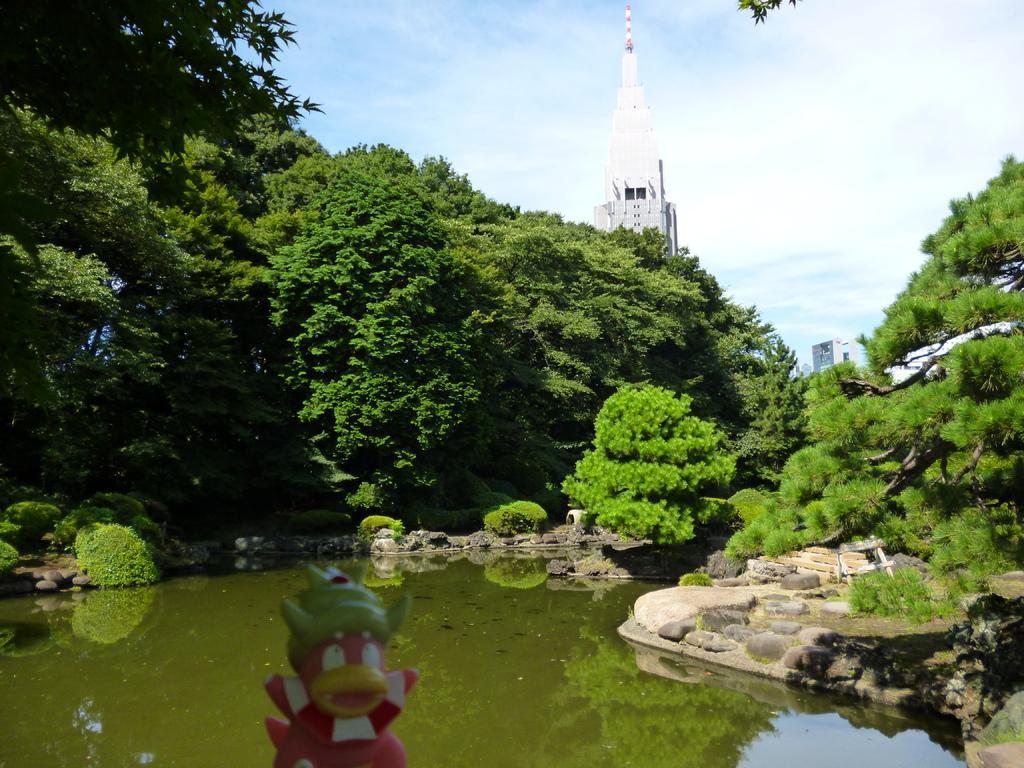In one or two sentences, can you explain what this image depicts? In this picture there is water and rocks at the bottom side of the image and there are trees in the center of the image and there is a tower in the background area of the image. 